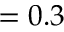Convert formula to latex. <formula><loc_0><loc_0><loc_500><loc_500>= 0 . 3</formula> 